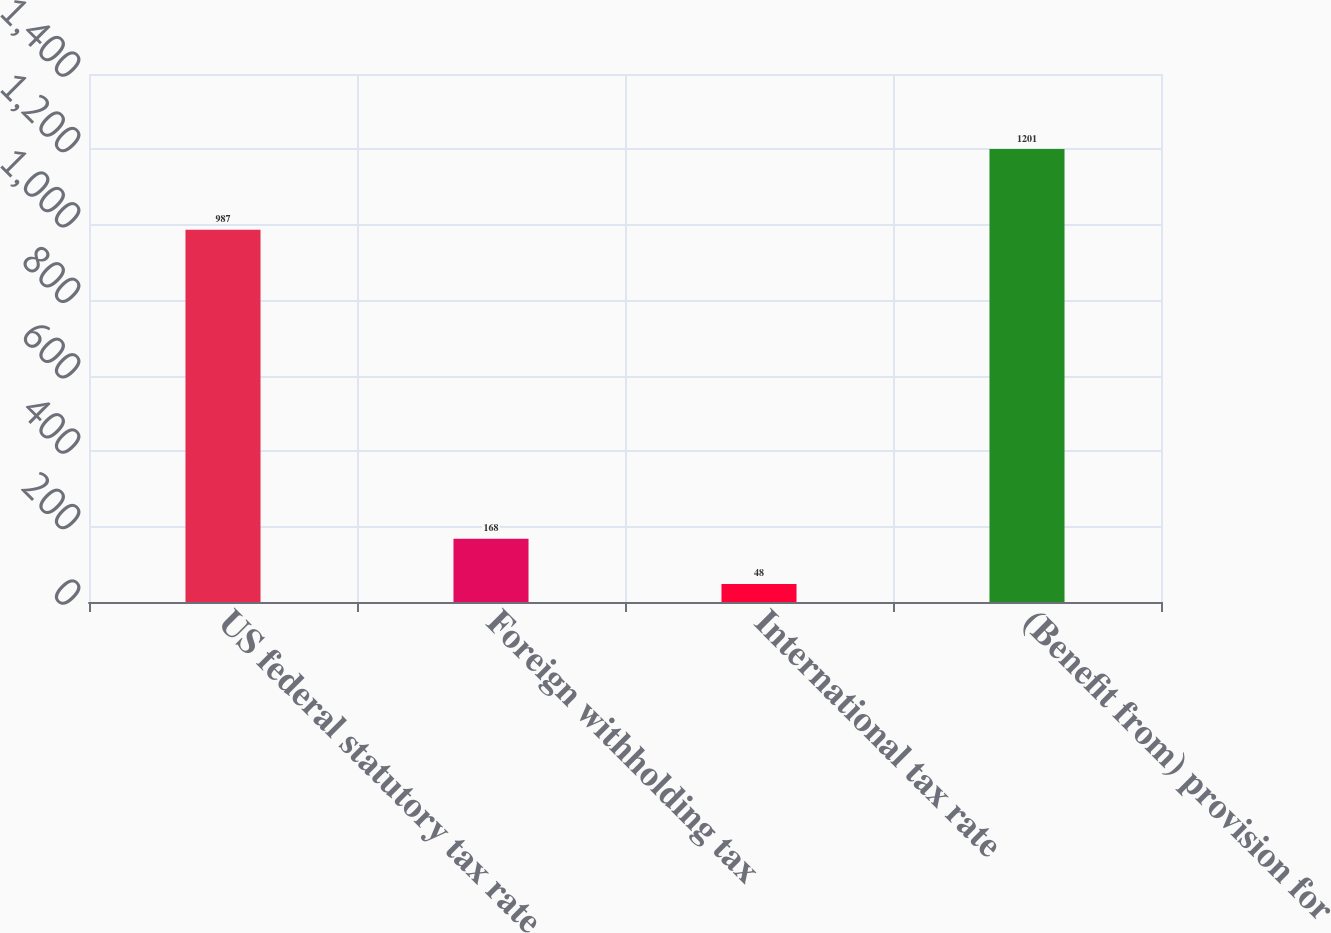Convert chart. <chart><loc_0><loc_0><loc_500><loc_500><bar_chart><fcel>US federal statutory tax rate<fcel>Foreign withholding tax<fcel>International tax rate<fcel>(Benefit from) provision for<nl><fcel>987<fcel>168<fcel>48<fcel>1201<nl></chart> 